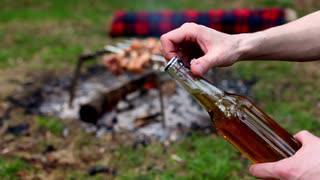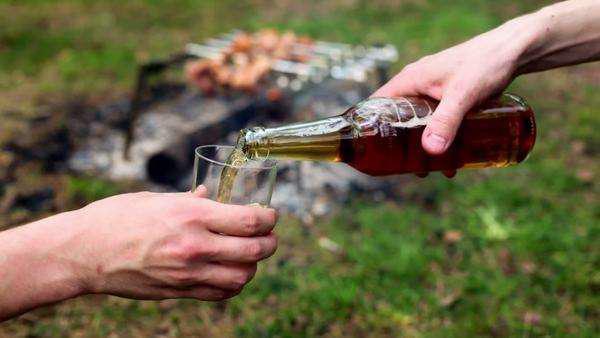The first image is the image on the left, the second image is the image on the right. Given the left and right images, does the statement "Both images are taken outdoors and in at least one of them, a campfire with food is in the background." hold true? Answer yes or no. Yes. The first image is the image on the left, the second image is the image on the right. Examine the images to the left and right. Is the description "People are clinking two brown bottles together in one of the images." accurate? Answer yes or no. No. 